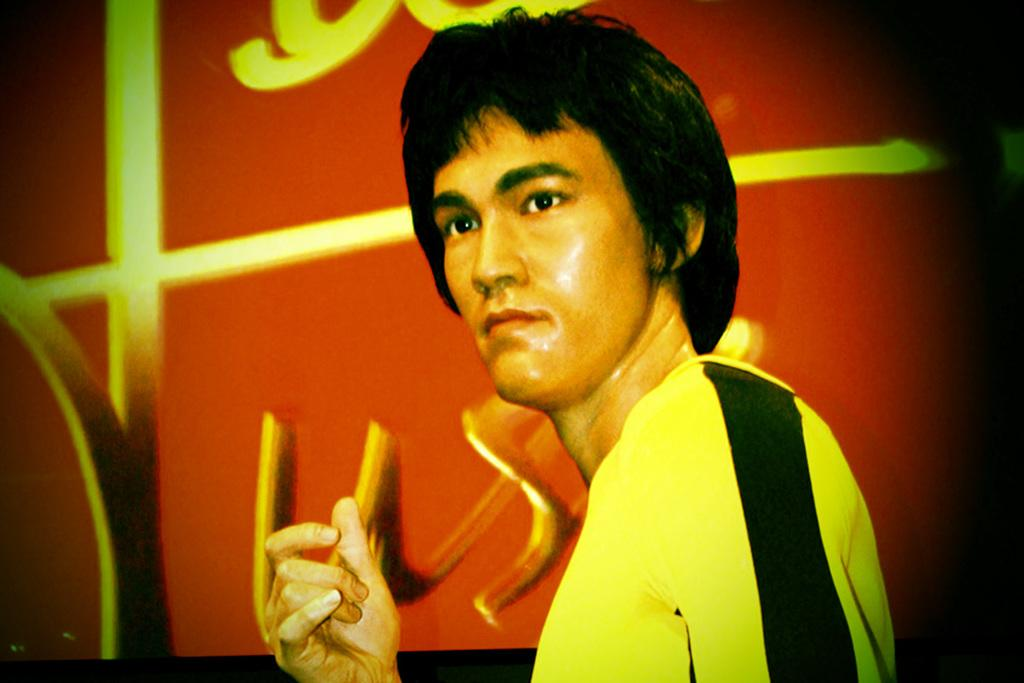Who is present in the image? There is a man in the picture. What is the man wearing? The man is wearing yellow and black color clothes. What can be seen in the background of the image? There is a red color object with designs in the background of the image. Can you describe the yoke that the man is using in the image? There is no yoke present in the image; the man is simply standing there wearing yellow and black color clothes. 